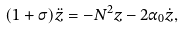Convert formula to latex. <formula><loc_0><loc_0><loc_500><loc_500>( 1 + \sigma ) \ddot { z } = - N ^ { 2 } z - 2 \alpha _ { 0 } \dot { z } ,</formula> 